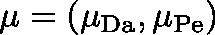<formula> <loc_0><loc_0><loc_500><loc_500>\mu = ( \mu _ { D a } , \mu _ { P e } )</formula> 